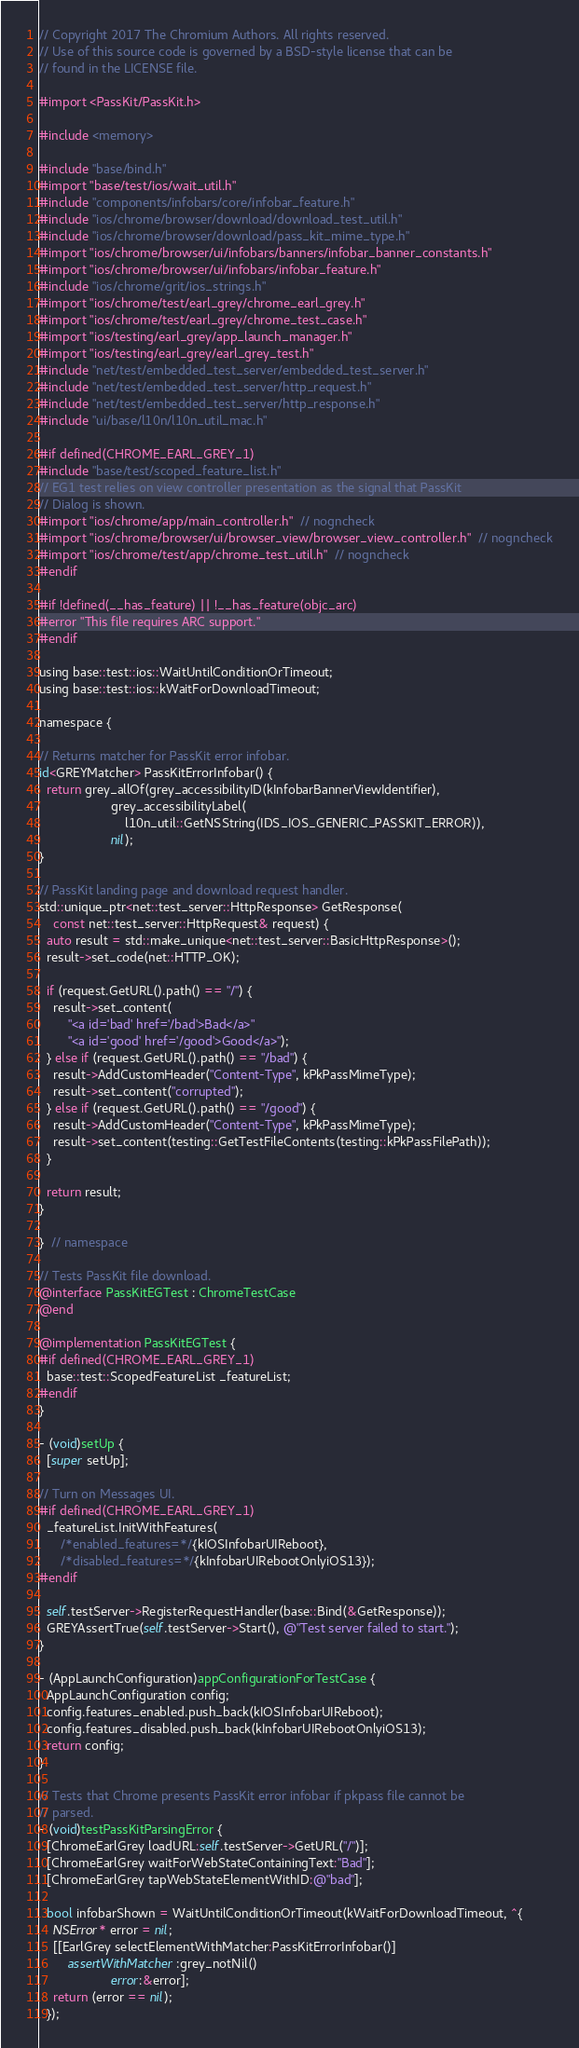<code> <loc_0><loc_0><loc_500><loc_500><_ObjectiveC_>// Copyright 2017 The Chromium Authors. All rights reserved.
// Use of this source code is governed by a BSD-style license that can be
// found in the LICENSE file.

#import <PassKit/PassKit.h>

#include <memory>

#include "base/bind.h"
#import "base/test/ios/wait_util.h"
#include "components/infobars/core/infobar_feature.h"
#include "ios/chrome/browser/download/download_test_util.h"
#include "ios/chrome/browser/download/pass_kit_mime_type.h"
#import "ios/chrome/browser/ui/infobars/banners/infobar_banner_constants.h"
#import "ios/chrome/browser/ui/infobars/infobar_feature.h"
#include "ios/chrome/grit/ios_strings.h"
#import "ios/chrome/test/earl_grey/chrome_earl_grey.h"
#import "ios/chrome/test/earl_grey/chrome_test_case.h"
#import "ios/testing/earl_grey/app_launch_manager.h"
#import "ios/testing/earl_grey/earl_grey_test.h"
#include "net/test/embedded_test_server/embedded_test_server.h"
#include "net/test/embedded_test_server/http_request.h"
#include "net/test/embedded_test_server/http_response.h"
#include "ui/base/l10n/l10n_util_mac.h"

#if defined(CHROME_EARL_GREY_1)
#include "base/test/scoped_feature_list.h"
// EG1 test relies on view controller presentation as the signal that PassKit
// Dialog is shown.
#import "ios/chrome/app/main_controller.h"  // nogncheck
#import "ios/chrome/browser/ui/browser_view/browser_view_controller.h"  // nogncheck
#import "ios/chrome/test/app/chrome_test_util.h"  // nogncheck
#endif

#if !defined(__has_feature) || !__has_feature(objc_arc)
#error "This file requires ARC support."
#endif

using base::test::ios::WaitUntilConditionOrTimeout;
using base::test::ios::kWaitForDownloadTimeout;

namespace {

// Returns matcher for PassKit error infobar.
id<GREYMatcher> PassKitErrorInfobar() {
  return grey_allOf(grey_accessibilityID(kInfobarBannerViewIdentifier),
                    grey_accessibilityLabel(
                        l10n_util::GetNSString(IDS_IOS_GENERIC_PASSKIT_ERROR)),
                    nil);
}

// PassKit landing page and download request handler.
std::unique_ptr<net::test_server::HttpResponse> GetResponse(
    const net::test_server::HttpRequest& request) {
  auto result = std::make_unique<net::test_server::BasicHttpResponse>();
  result->set_code(net::HTTP_OK);

  if (request.GetURL().path() == "/") {
    result->set_content(
        "<a id='bad' href='/bad'>Bad</a>"
        "<a id='good' href='/good'>Good</a>");
  } else if (request.GetURL().path() == "/bad") {
    result->AddCustomHeader("Content-Type", kPkPassMimeType);
    result->set_content("corrupted");
  } else if (request.GetURL().path() == "/good") {
    result->AddCustomHeader("Content-Type", kPkPassMimeType);
    result->set_content(testing::GetTestFileContents(testing::kPkPassFilePath));
  }

  return result;
}

}  // namespace

// Tests PassKit file download.
@interface PassKitEGTest : ChromeTestCase
@end

@implementation PassKitEGTest {
#if defined(CHROME_EARL_GREY_1)
  base::test::ScopedFeatureList _featureList;
#endif
}

- (void)setUp {
  [super setUp];

// Turn on Messages UI.
#if defined(CHROME_EARL_GREY_1)
  _featureList.InitWithFeatures(
      /*enabled_features=*/{kIOSInfobarUIReboot},
      /*disabled_features=*/{kInfobarUIRebootOnlyiOS13});
#endif

  self.testServer->RegisterRequestHandler(base::Bind(&GetResponse));
  GREYAssertTrue(self.testServer->Start(), @"Test server failed to start.");
}

- (AppLaunchConfiguration)appConfigurationForTestCase {
  AppLaunchConfiguration config;
  config.features_enabled.push_back(kIOSInfobarUIReboot);
  config.features_disabled.push_back(kInfobarUIRebootOnlyiOS13);
  return config;
}

// Tests that Chrome presents PassKit error infobar if pkpass file cannot be
// parsed.
- (void)testPassKitParsingError {
  [ChromeEarlGrey loadURL:self.testServer->GetURL("/")];
  [ChromeEarlGrey waitForWebStateContainingText:"Bad"];
  [ChromeEarlGrey tapWebStateElementWithID:@"bad"];

  bool infobarShown = WaitUntilConditionOrTimeout(kWaitForDownloadTimeout, ^{
    NSError* error = nil;
    [[EarlGrey selectElementWithMatcher:PassKitErrorInfobar()]
        assertWithMatcher:grey_notNil()
                    error:&error];
    return (error == nil);
  });</code> 